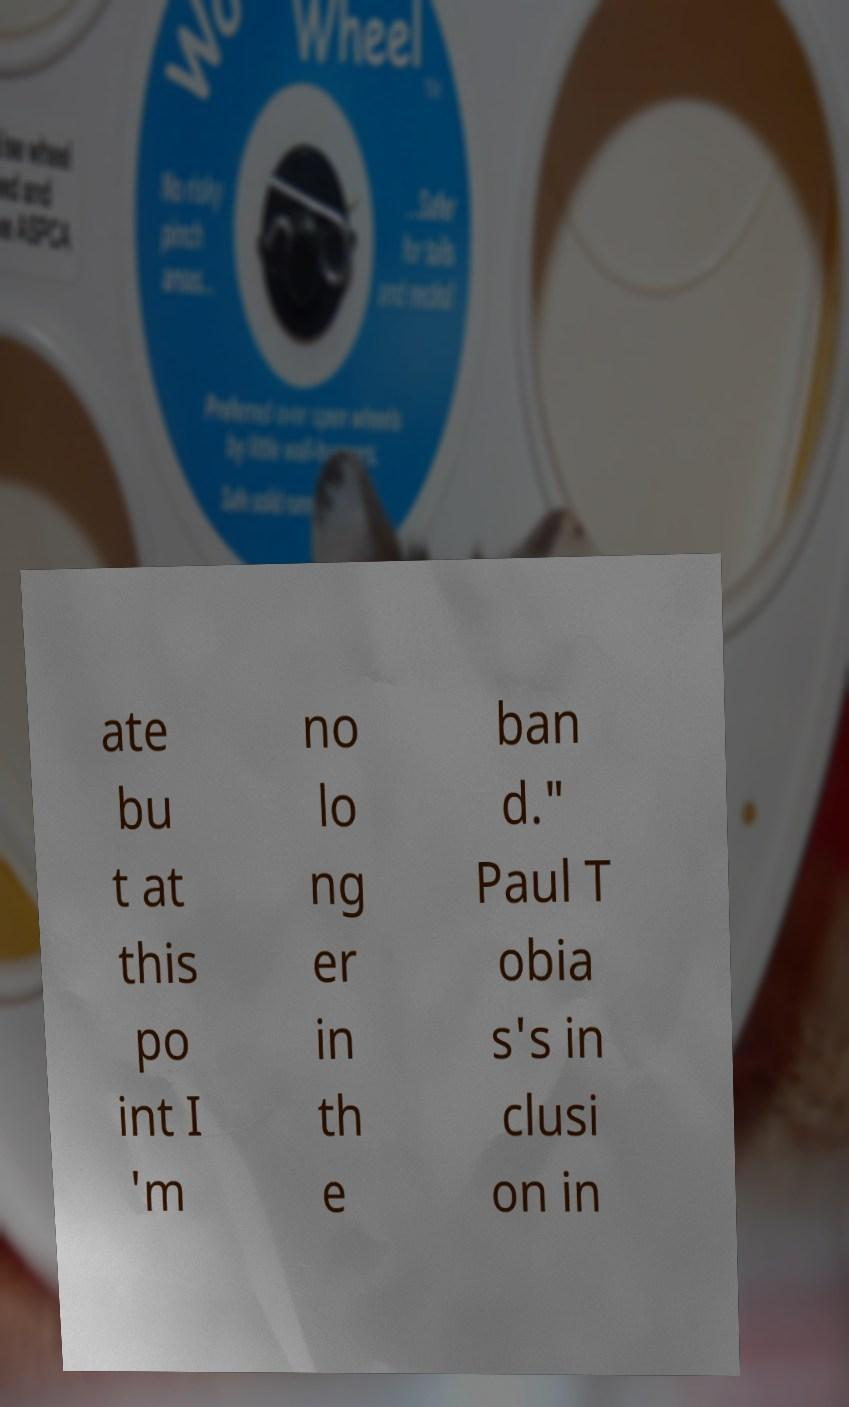I need the written content from this picture converted into text. Can you do that? ate bu t at this po int I 'm no lo ng er in th e ban d." Paul T obia s's in clusi on in 